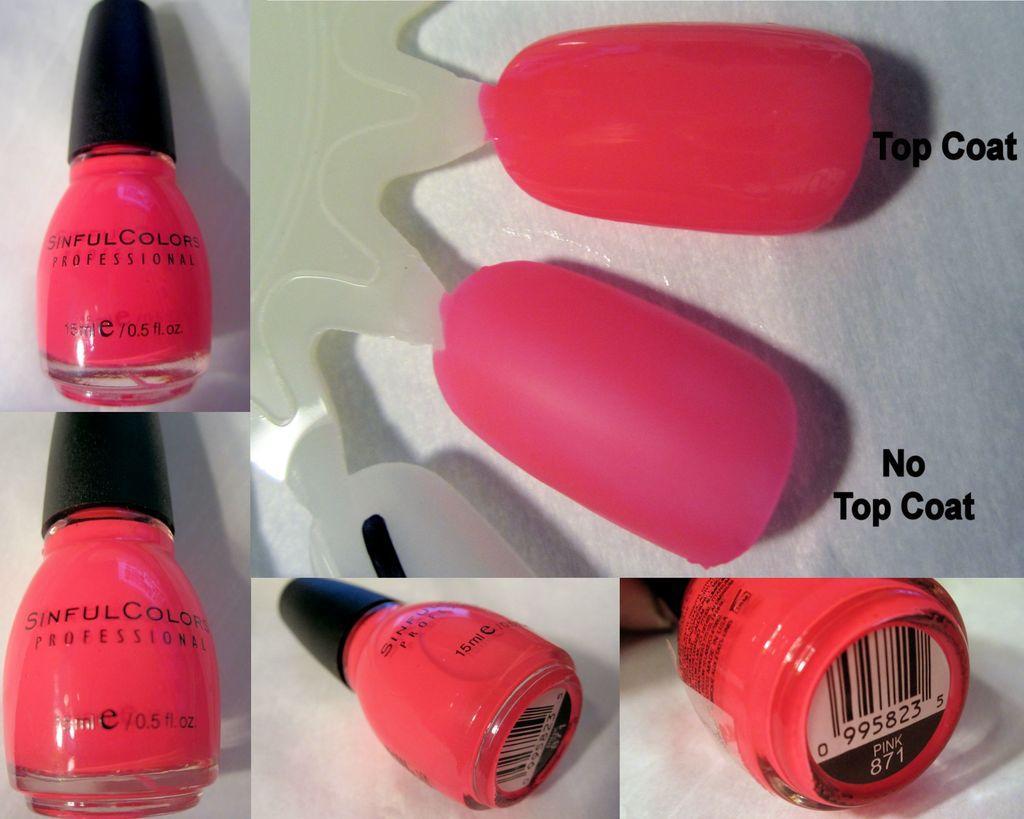Describe this image in one or two sentences. This image consists of nails and nail polishes. This is an edited image. It is in pink color. 